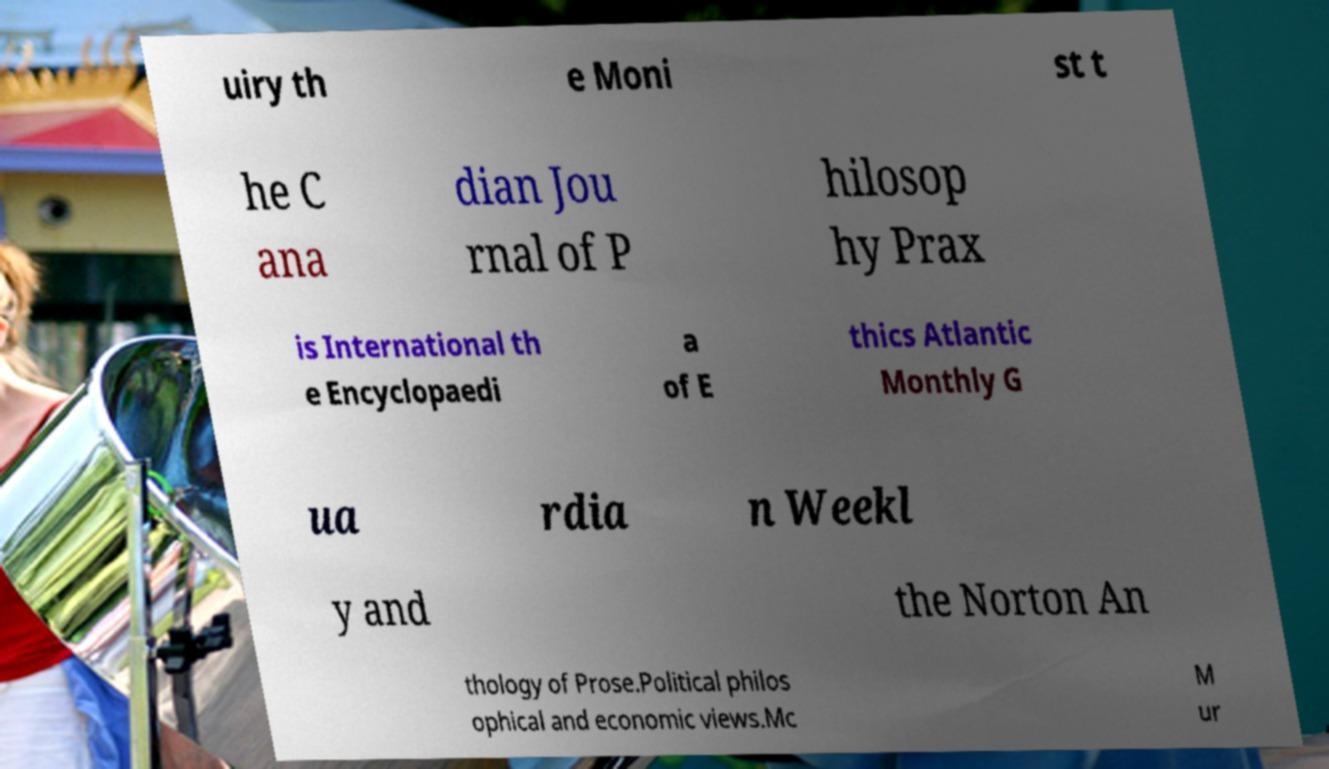Can you read and provide the text displayed in the image?This photo seems to have some interesting text. Can you extract and type it out for me? uiry th e Moni st t he C ana dian Jou rnal of P hilosop hy Prax is International th e Encyclopaedi a of E thics Atlantic Monthly G ua rdia n Weekl y and the Norton An thology of Prose.Political philos ophical and economic views.Mc M ur 